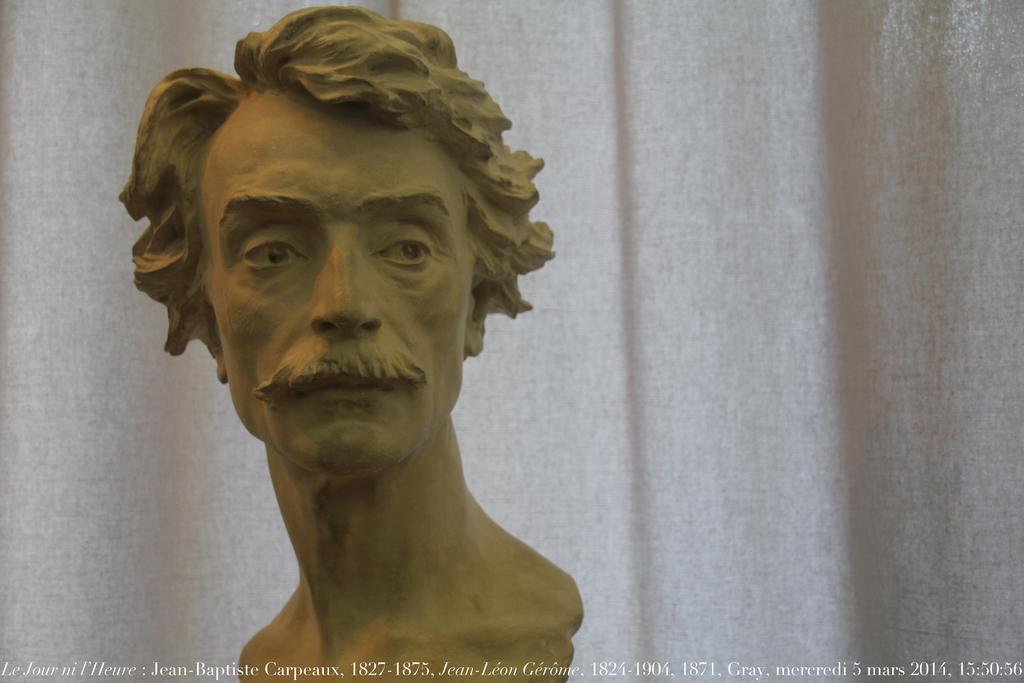How would you summarize this image in a sentence or two? In the image we can see there is a statue of a man and behind there is a white colour curtain. 